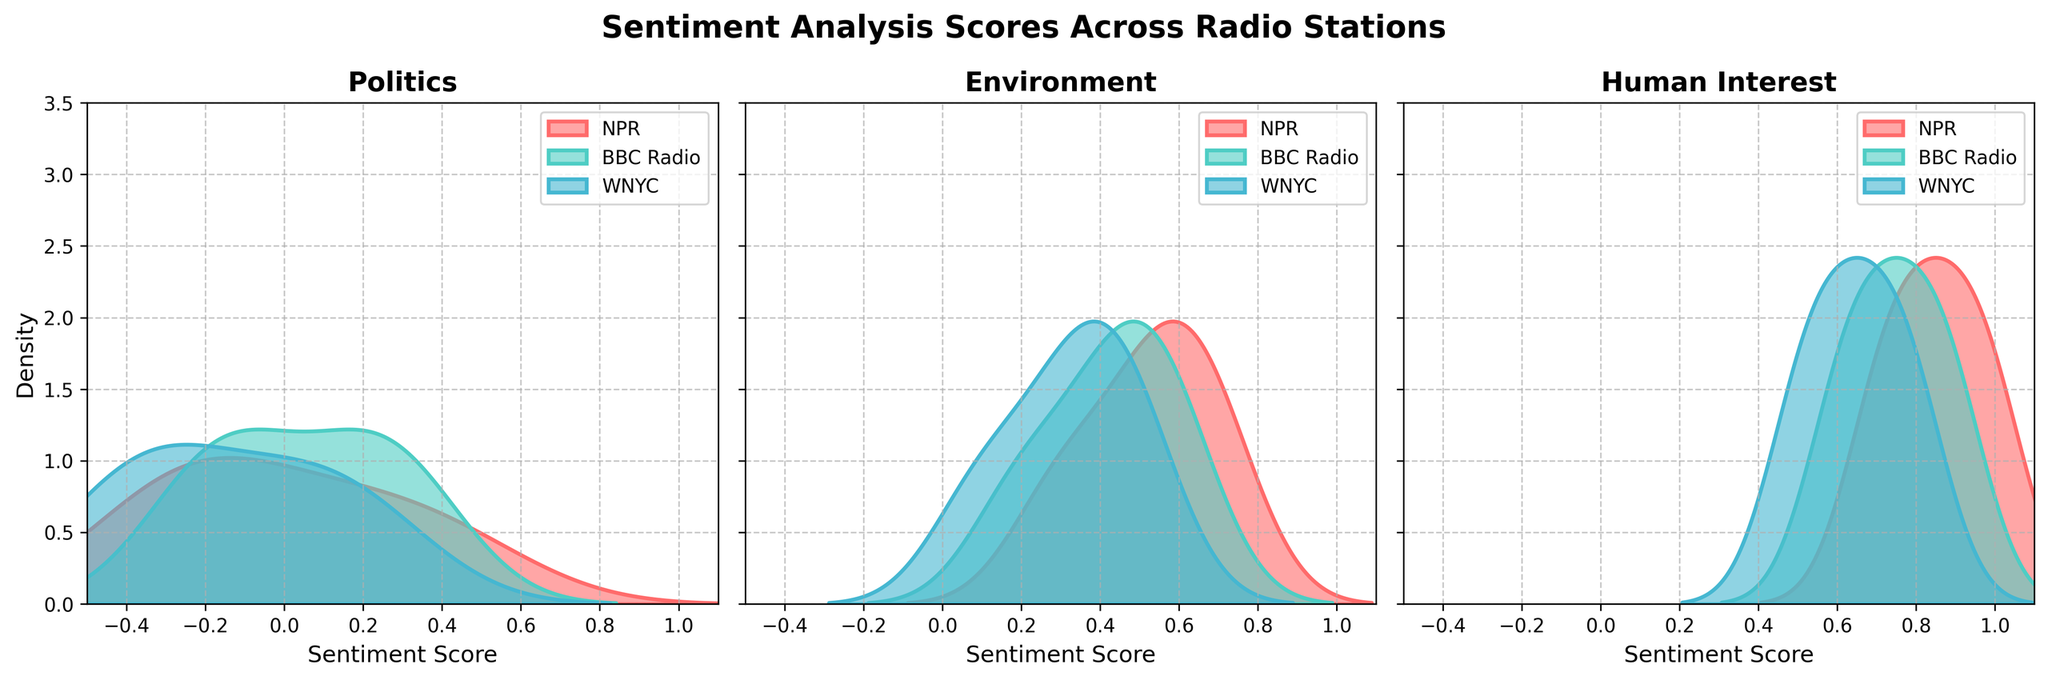What is the title of the figure? The title is displayed prominently at the top center of the figure. It usually provides a summary of what the figure represents.
Answer: Sentiment Analysis Scores Across Radio Stations Which radio station's sentiment scores for the Politics topic have a peak density closest to -0.2? By observing the curves in the Politics subplot, the peak density closest to -0.2 can be identified for each station.
Answer: WNYC Among the three radio stations, which one shows the highest peak density for the Environment topic? By comparing the height of the peaks for the Environment topic curves for NPR, BBC Radio, and WNYC, the highest peak can be identified.
Answer: NPR In Human Interest, which station's sentiment scores show the most positive range? Look at the range of the density curves for Human Interest. Identify which station reaches closer to the maximum sentiment score, which is 1.0.
Answer: NPR What is the common x-axis label across all subplots? Each subplot utilizes a common x-axis label, which is usually visible beneath the horizontal axis of each plot.
Answer: Sentiment Score Which subplot generally shows the most positive sentiment scores across all stations? By comparing the ranges and peaks of sentiment scores in Politics, Environment, and Human Interest subplots, the one with scores skewed more positively overall can be identified.
Answer: Human Interest What density level does the NPR's sentiment score curve reach at its peak for the Environment topic? Identify the peak point on the NPR density curve within the Environment subplot and note the corresponding density level on the vertical axis.
Answer: Approximately 2.8 Does BBC Radio have any topic with sentiment scores predominantly above zero? For each topic subplot, check the BBC Radio curves' ranges to determine if any of them primarily occupy the positive sentiment score range.
Answer: Yes, Human Interest and Environment In the Politics subplot, between NPR and BBC Radio, which station has sentiment scores that show more variability? By observing the spread and range of the density curves for NPR and BBC Radio in the Politics subplot, the station with wider variability in scores can be determined.
Answer: NPR How does the density curve for WNYC's Human Interest topic compare to NPR's in terms of peak height? Compare the heights of the density curves for WNYC and NPR within the Human Interest subplot to see which station has a taller peak or if they are similar.
Answer: WNYC's peak is slightly lower What are the colors used for each radio station's curves, and how can they be identified in the subplots? The colors for NPR, BBC Radio, and WNYC are consistent across all subplots and are indicated in the legend. By checking the legend, the corresponding color for each station can be determined.
Answer: NPR: Red, BBC Radio: Teal, WNYC: Blue 